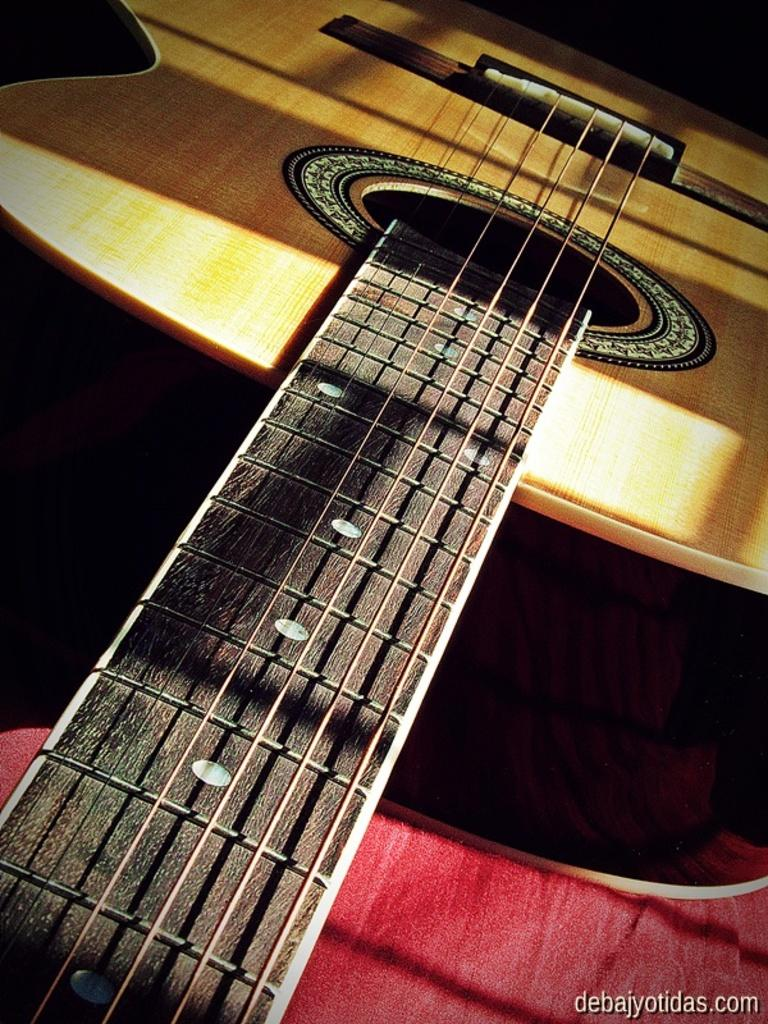What musical instrument is present in the image? There is a guitar in the image. What type of drink is being served in the guitar's frame in the image? There is no frame or drink present in the image; it only features a guitar. 